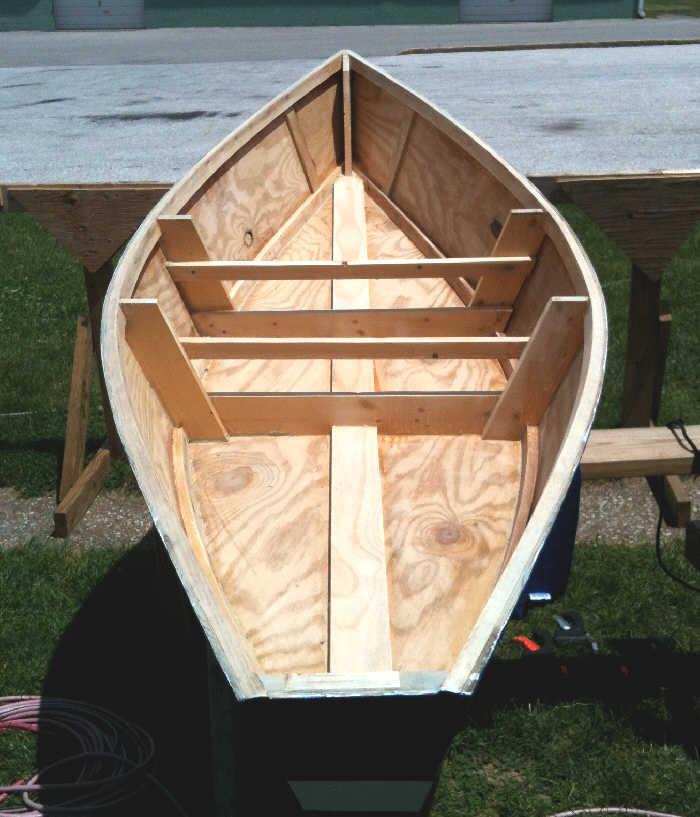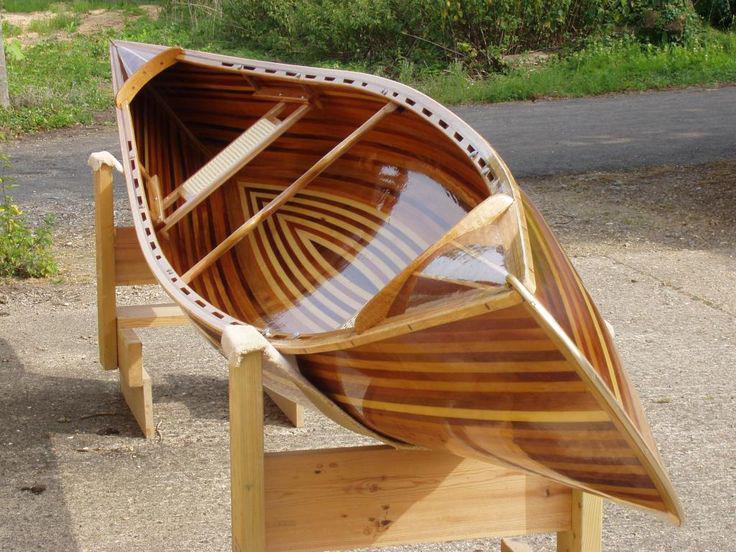The first image is the image on the left, the second image is the image on the right. Considering the images on both sides, is "there are two boats in the image pair" valid? Answer yes or no. Yes. The first image is the image on the left, the second image is the image on the right. Assess this claim about the two images: "There is at least one boat in storage.". Correct or not? Answer yes or no. No. 